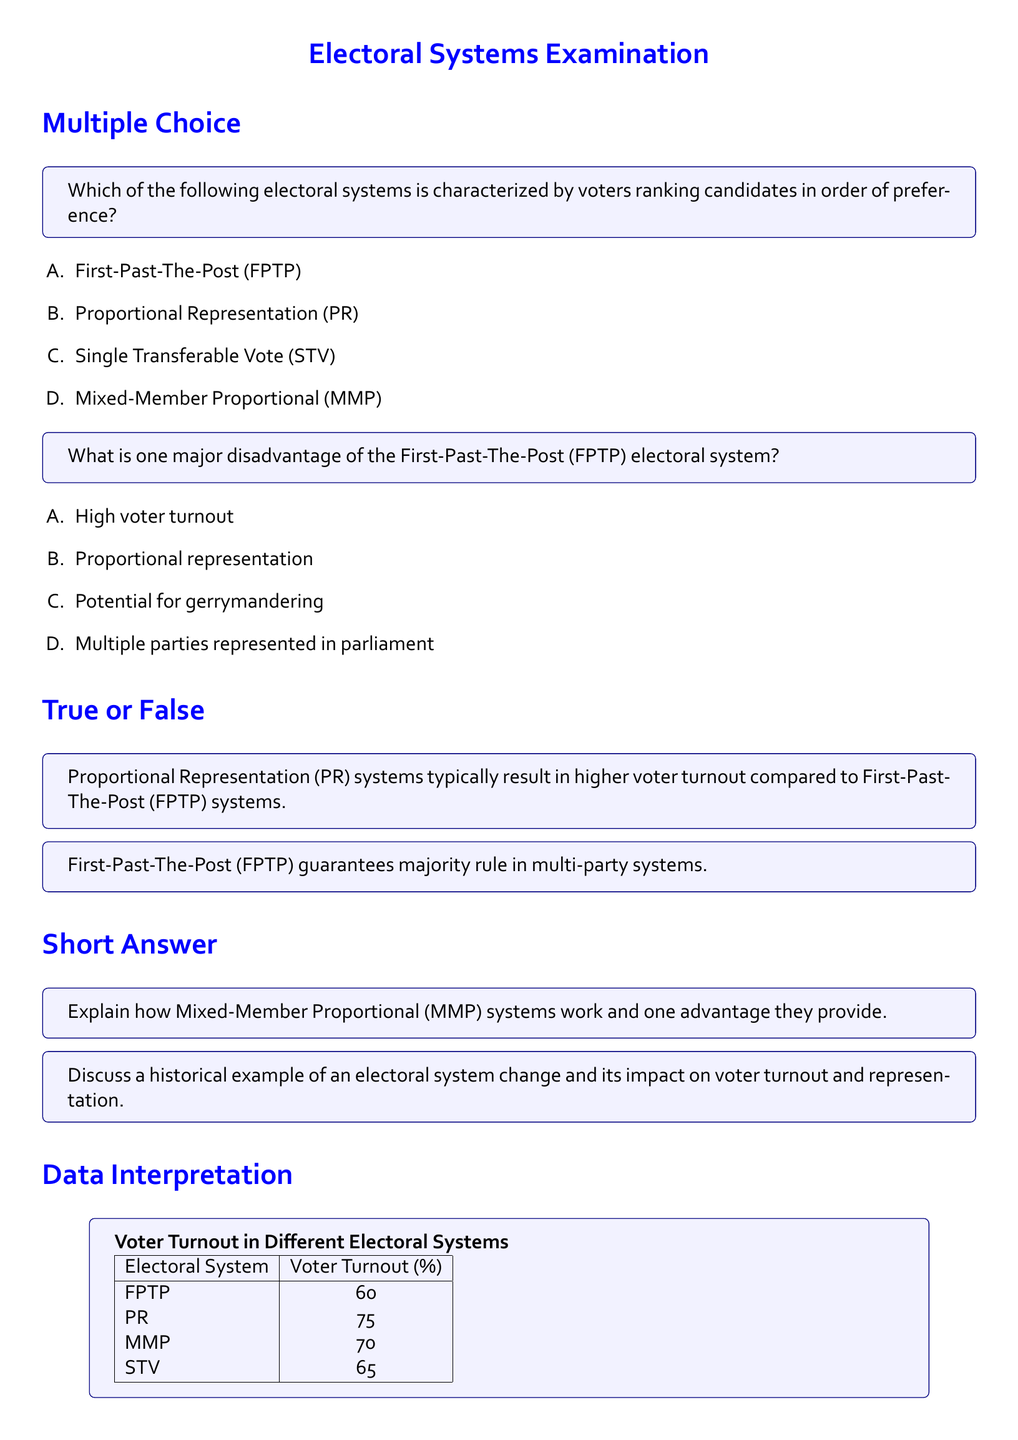What is the voter turnout percentage for Proportional Representation (PR)? According to the data provided in the document, Voter Turnout for PR is directly stated in the table.
Answer: 75 Which electoral system has the lowest voter turnout? The table displays the voter turnout percentages for each electoral system, indicating which one is the lowest.
Answer: FPTP How many electoral systems are mentioned in the document? The document lists four electoral systems in the data section, requiring a count of these items.
Answer: 4 What is a major disadvantage of the First-Past-The-Post (FPTP) system? The document provides specific disadvantages for each electoral system as part of multiple-choice questions, highlighting FPTP's drawback.
Answer: Potential for gerrymandering What is the voter turnout percentage for Single Transferable Vote (STV)? The document includes a table that specifies the voter turnout percentages for various systems, including STV.
Answer: 65 Which electoral system is associated with the highest voter turnout? The document's data table allows a comparative analysis to identify which system has the highest recorded turnout percentage.
Answer: PR What advantage does the Mixed-Member Proportional (MMP) system provide? The short-answer question prompts reflection on the advantages of the MMP system as presented in the document's content.
Answer: Improved representation What type of electoral system is characterized by voters ranking candidates? According to the questions presented, this system is aligned with a specific format described in one of the choices.
Answer: Single Transferable Vote (STV) 